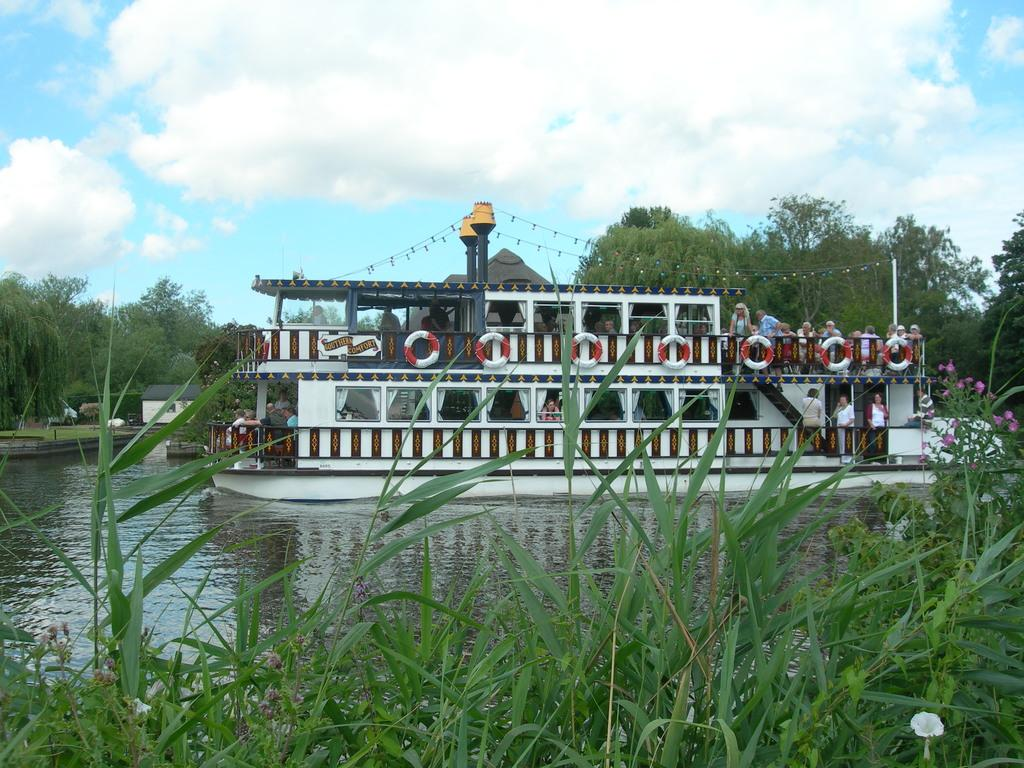What is the main subject of the image? The main subject of the image is a boat. Where is the boat located? The boat is in a pond. Are there any people in the image? Yes, there are people standing inside the boat. What can be seen in front of the boat? There is grass in front of the boat. What is visible behind the boat? There are trees behind the boat. What is visible above the boat? The sky is visible above the boat. Can you describe the sky in the image? Clouds are present in the sky. Can you hear the people in the boat laughing in the image? There is no sound present in the image, so it is not possible to determine if the people are laughing or not. 